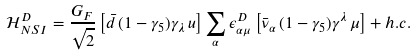Convert formula to latex. <formula><loc_0><loc_0><loc_500><loc_500>\mathcal { H } _ { N S I } ^ { D } = \frac { G _ { F } } { \sqrt { 2 } } \left [ \bar { d } \, ( 1 - \gamma _ { 5 } ) \gamma _ { \lambda } \, u \right ] \sum _ { \alpha } \epsilon _ { \alpha \mu } ^ { D } \left [ \bar { \nu } _ { \alpha } \, ( 1 - \gamma _ { 5 } ) \gamma ^ { \lambda } \, \mu \right ] + h . c .</formula> 